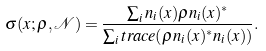<formula> <loc_0><loc_0><loc_500><loc_500>\sigma ( x ; \rho , \mathcal { N } ) = \frac { \sum _ { i } n _ { i } ( x ) \rho n _ { i } ( x ) ^ { * } } { \sum _ { i } t r a c e ( \rho n _ { i } ( x ) ^ { * } n _ { i } ( x ) ) } .</formula> 